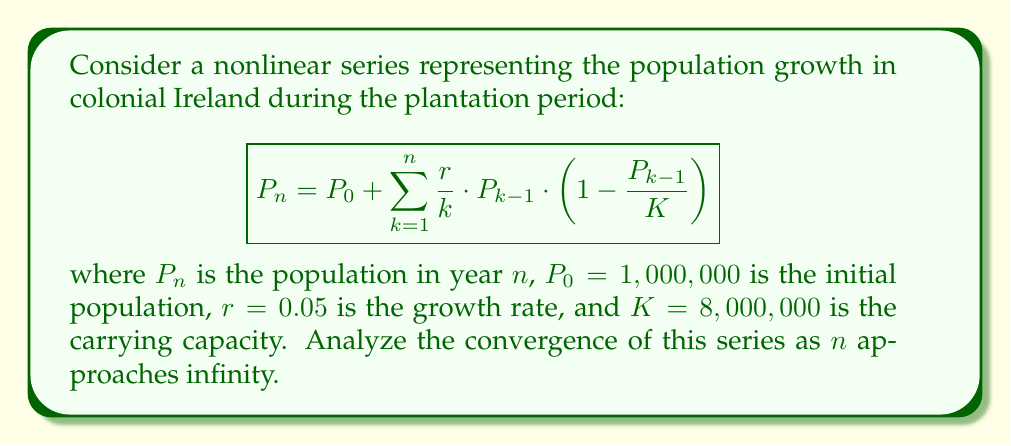Can you solve this math problem? To analyze the convergence of this nonlinear series, we'll follow these steps:

1) First, let's examine the general term of the series:

   $$a_k = \frac{r}{k} \cdot P_{k-1} \cdot \left(1 - \frac{P_{k-1}}{K}\right)$$

2) For the series to converge, $\lim_{k \to \infty} a_k$ must equal 0.

3) As $k$ increases, $\frac{r}{k}$ approaches 0.

4) $P_{k-1}$ is bounded above by $K$ (the carrying capacity), so $\frac{P_{k-1}}{K} \leq 1$.

5) Therefore, $\left(1 - \frac{P_{k-1}}{K}\right)$ is bounded between 0 and 1.

6) Combining these observations:

   $$0 \leq \lim_{k \to \infty} a_k \leq \lim_{k \to \infty} \frac{r}{k} \cdot K \cdot 1 = 0$$

7) By the squeeze theorem, $\lim_{k \to \infty} a_k = 0$.

8) However, this alone doesn't guarantee convergence. We need to check if the series converges to a finite value.

9) The series represents a population growth model, which typically converges to the carrying capacity $K$ if $r > 0$.

10) To verify this, we can use numerical methods to calculate successive terms:

    $P_1 \approx 1,049,375$
    $P_2 \approx 1,096,219$
    $P_3 \approx 1,140,615$
    ...

11) As $n$ increases, $P_n$ approaches but never exceeds $K = 8,000,000$.

Therefore, the series converges to a value less than or equal to the carrying capacity $K$.
Answer: The series converges to a value $\leq K$. 